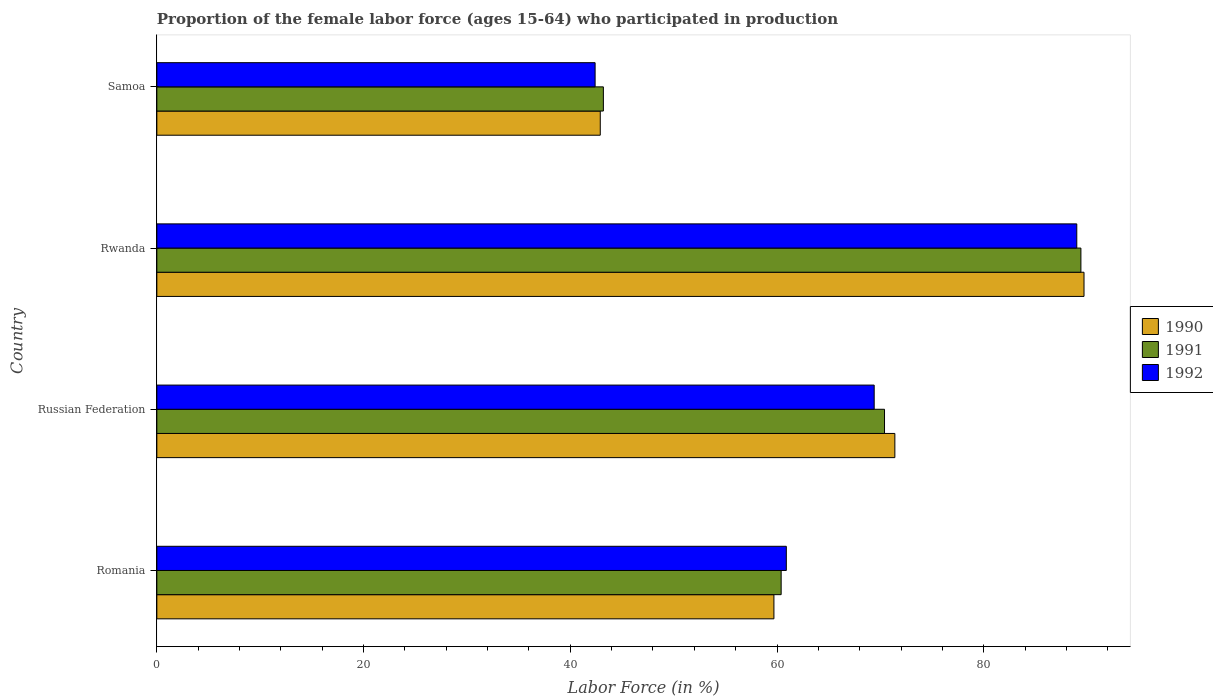How many groups of bars are there?
Your answer should be compact. 4. Are the number of bars per tick equal to the number of legend labels?
Provide a short and direct response. Yes. Are the number of bars on each tick of the Y-axis equal?
Ensure brevity in your answer.  Yes. How many bars are there on the 2nd tick from the top?
Keep it short and to the point. 3. What is the label of the 3rd group of bars from the top?
Provide a short and direct response. Russian Federation. In how many cases, is the number of bars for a given country not equal to the number of legend labels?
Your answer should be compact. 0. What is the proportion of the female labor force who participated in production in 1991 in Romania?
Your answer should be compact. 60.4. Across all countries, what is the maximum proportion of the female labor force who participated in production in 1991?
Ensure brevity in your answer.  89.4. Across all countries, what is the minimum proportion of the female labor force who participated in production in 1992?
Provide a short and direct response. 42.4. In which country was the proportion of the female labor force who participated in production in 1992 maximum?
Provide a short and direct response. Rwanda. In which country was the proportion of the female labor force who participated in production in 1992 minimum?
Keep it short and to the point. Samoa. What is the total proportion of the female labor force who participated in production in 1992 in the graph?
Your answer should be very brief. 261.7. What is the difference between the proportion of the female labor force who participated in production in 1990 in Romania and that in Rwanda?
Offer a very short reply. -30. What is the difference between the proportion of the female labor force who participated in production in 1992 in Russian Federation and the proportion of the female labor force who participated in production in 1991 in Rwanda?
Your response must be concise. -20. What is the average proportion of the female labor force who participated in production in 1992 per country?
Your answer should be very brief. 65.43. What is the difference between the proportion of the female labor force who participated in production in 1991 and proportion of the female labor force who participated in production in 1992 in Rwanda?
Ensure brevity in your answer.  0.4. What is the ratio of the proportion of the female labor force who participated in production in 1990 in Romania to that in Rwanda?
Your response must be concise. 0.67. Is the proportion of the female labor force who participated in production in 1990 in Russian Federation less than that in Rwanda?
Give a very brief answer. Yes. What is the difference between the highest and the lowest proportion of the female labor force who participated in production in 1991?
Provide a succinct answer. 46.2. What does the 3rd bar from the top in Rwanda represents?
Offer a very short reply. 1990. What does the 3rd bar from the bottom in Romania represents?
Your response must be concise. 1992. Are all the bars in the graph horizontal?
Your answer should be compact. Yes. Does the graph contain grids?
Give a very brief answer. No. How many legend labels are there?
Make the answer very short. 3. What is the title of the graph?
Keep it short and to the point. Proportion of the female labor force (ages 15-64) who participated in production. What is the Labor Force (in %) in 1990 in Romania?
Your response must be concise. 59.7. What is the Labor Force (in %) of 1991 in Romania?
Your response must be concise. 60.4. What is the Labor Force (in %) of 1992 in Romania?
Your answer should be compact. 60.9. What is the Labor Force (in %) of 1990 in Russian Federation?
Your response must be concise. 71.4. What is the Labor Force (in %) of 1991 in Russian Federation?
Your answer should be compact. 70.4. What is the Labor Force (in %) of 1992 in Russian Federation?
Make the answer very short. 69.4. What is the Labor Force (in %) of 1990 in Rwanda?
Give a very brief answer. 89.7. What is the Labor Force (in %) in 1991 in Rwanda?
Provide a succinct answer. 89.4. What is the Labor Force (in %) in 1992 in Rwanda?
Make the answer very short. 89. What is the Labor Force (in %) in 1990 in Samoa?
Offer a very short reply. 42.9. What is the Labor Force (in %) of 1991 in Samoa?
Keep it short and to the point. 43.2. What is the Labor Force (in %) of 1992 in Samoa?
Make the answer very short. 42.4. Across all countries, what is the maximum Labor Force (in %) of 1990?
Offer a very short reply. 89.7. Across all countries, what is the maximum Labor Force (in %) of 1991?
Your answer should be compact. 89.4. Across all countries, what is the maximum Labor Force (in %) of 1992?
Keep it short and to the point. 89. Across all countries, what is the minimum Labor Force (in %) in 1990?
Make the answer very short. 42.9. Across all countries, what is the minimum Labor Force (in %) in 1991?
Your answer should be compact. 43.2. Across all countries, what is the minimum Labor Force (in %) in 1992?
Provide a succinct answer. 42.4. What is the total Labor Force (in %) in 1990 in the graph?
Your answer should be very brief. 263.7. What is the total Labor Force (in %) in 1991 in the graph?
Ensure brevity in your answer.  263.4. What is the total Labor Force (in %) in 1992 in the graph?
Your response must be concise. 261.7. What is the difference between the Labor Force (in %) in 1990 in Romania and that in Rwanda?
Provide a succinct answer. -30. What is the difference between the Labor Force (in %) in 1992 in Romania and that in Rwanda?
Your answer should be very brief. -28.1. What is the difference between the Labor Force (in %) of 1991 in Romania and that in Samoa?
Give a very brief answer. 17.2. What is the difference between the Labor Force (in %) of 1992 in Romania and that in Samoa?
Keep it short and to the point. 18.5. What is the difference between the Labor Force (in %) in 1990 in Russian Federation and that in Rwanda?
Offer a terse response. -18.3. What is the difference between the Labor Force (in %) in 1992 in Russian Federation and that in Rwanda?
Make the answer very short. -19.6. What is the difference between the Labor Force (in %) in 1990 in Russian Federation and that in Samoa?
Provide a short and direct response. 28.5. What is the difference between the Labor Force (in %) of 1991 in Russian Federation and that in Samoa?
Make the answer very short. 27.2. What is the difference between the Labor Force (in %) of 1990 in Rwanda and that in Samoa?
Provide a succinct answer. 46.8. What is the difference between the Labor Force (in %) of 1991 in Rwanda and that in Samoa?
Your answer should be very brief. 46.2. What is the difference between the Labor Force (in %) of 1992 in Rwanda and that in Samoa?
Ensure brevity in your answer.  46.6. What is the difference between the Labor Force (in %) in 1990 in Romania and the Labor Force (in %) in 1991 in Russian Federation?
Provide a short and direct response. -10.7. What is the difference between the Labor Force (in %) in 1990 in Romania and the Labor Force (in %) in 1992 in Russian Federation?
Offer a very short reply. -9.7. What is the difference between the Labor Force (in %) of 1991 in Romania and the Labor Force (in %) of 1992 in Russian Federation?
Your answer should be compact. -9. What is the difference between the Labor Force (in %) in 1990 in Romania and the Labor Force (in %) in 1991 in Rwanda?
Your response must be concise. -29.7. What is the difference between the Labor Force (in %) of 1990 in Romania and the Labor Force (in %) of 1992 in Rwanda?
Keep it short and to the point. -29.3. What is the difference between the Labor Force (in %) in 1991 in Romania and the Labor Force (in %) in 1992 in Rwanda?
Provide a short and direct response. -28.6. What is the difference between the Labor Force (in %) in 1990 in Romania and the Labor Force (in %) in 1992 in Samoa?
Provide a succinct answer. 17.3. What is the difference between the Labor Force (in %) of 1990 in Russian Federation and the Labor Force (in %) of 1991 in Rwanda?
Keep it short and to the point. -18. What is the difference between the Labor Force (in %) of 1990 in Russian Federation and the Labor Force (in %) of 1992 in Rwanda?
Keep it short and to the point. -17.6. What is the difference between the Labor Force (in %) in 1991 in Russian Federation and the Labor Force (in %) in 1992 in Rwanda?
Make the answer very short. -18.6. What is the difference between the Labor Force (in %) of 1990 in Russian Federation and the Labor Force (in %) of 1991 in Samoa?
Give a very brief answer. 28.2. What is the difference between the Labor Force (in %) of 1990 in Rwanda and the Labor Force (in %) of 1991 in Samoa?
Ensure brevity in your answer.  46.5. What is the difference between the Labor Force (in %) in 1990 in Rwanda and the Labor Force (in %) in 1992 in Samoa?
Make the answer very short. 47.3. What is the difference between the Labor Force (in %) in 1991 in Rwanda and the Labor Force (in %) in 1992 in Samoa?
Your answer should be compact. 47. What is the average Labor Force (in %) in 1990 per country?
Your answer should be compact. 65.92. What is the average Labor Force (in %) in 1991 per country?
Your answer should be compact. 65.85. What is the average Labor Force (in %) of 1992 per country?
Give a very brief answer. 65.42. What is the difference between the Labor Force (in %) of 1990 and Labor Force (in %) of 1991 in Romania?
Offer a very short reply. -0.7. What is the difference between the Labor Force (in %) in 1990 and Labor Force (in %) in 1992 in Romania?
Offer a terse response. -1.2. What is the difference between the Labor Force (in %) of 1990 and Labor Force (in %) of 1992 in Russian Federation?
Make the answer very short. 2. What is the difference between the Labor Force (in %) of 1990 and Labor Force (in %) of 1991 in Rwanda?
Your answer should be compact. 0.3. What is the difference between the Labor Force (in %) of 1991 and Labor Force (in %) of 1992 in Rwanda?
Provide a succinct answer. 0.4. What is the ratio of the Labor Force (in %) of 1990 in Romania to that in Russian Federation?
Offer a very short reply. 0.84. What is the ratio of the Labor Force (in %) of 1991 in Romania to that in Russian Federation?
Your answer should be compact. 0.86. What is the ratio of the Labor Force (in %) in 1992 in Romania to that in Russian Federation?
Keep it short and to the point. 0.88. What is the ratio of the Labor Force (in %) in 1990 in Romania to that in Rwanda?
Keep it short and to the point. 0.67. What is the ratio of the Labor Force (in %) of 1991 in Romania to that in Rwanda?
Provide a succinct answer. 0.68. What is the ratio of the Labor Force (in %) of 1992 in Romania to that in Rwanda?
Keep it short and to the point. 0.68. What is the ratio of the Labor Force (in %) in 1990 in Romania to that in Samoa?
Offer a very short reply. 1.39. What is the ratio of the Labor Force (in %) in 1991 in Romania to that in Samoa?
Your response must be concise. 1.4. What is the ratio of the Labor Force (in %) in 1992 in Romania to that in Samoa?
Offer a terse response. 1.44. What is the ratio of the Labor Force (in %) in 1990 in Russian Federation to that in Rwanda?
Offer a terse response. 0.8. What is the ratio of the Labor Force (in %) in 1991 in Russian Federation to that in Rwanda?
Provide a succinct answer. 0.79. What is the ratio of the Labor Force (in %) in 1992 in Russian Federation to that in Rwanda?
Your response must be concise. 0.78. What is the ratio of the Labor Force (in %) in 1990 in Russian Federation to that in Samoa?
Ensure brevity in your answer.  1.66. What is the ratio of the Labor Force (in %) in 1991 in Russian Federation to that in Samoa?
Your answer should be compact. 1.63. What is the ratio of the Labor Force (in %) of 1992 in Russian Federation to that in Samoa?
Your response must be concise. 1.64. What is the ratio of the Labor Force (in %) of 1990 in Rwanda to that in Samoa?
Your response must be concise. 2.09. What is the ratio of the Labor Force (in %) in 1991 in Rwanda to that in Samoa?
Provide a short and direct response. 2.07. What is the ratio of the Labor Force (in %) in 1992 in Rwanda to that in Samoa?
Provide a succinct answer. 2.1. What is the difference between the highest and the second highest Labor Force (in %) in 1990?
Provide a succinct answer. 18.3. What is the difference between the highest and the second highest Labor Force (in %) of 1992?
Ensure brevity in your answer.  19.6. What is the difference between the highest and the lowest Labor Force (in %) in 1990?
Your answer should be compact. 46.8. What is the difference between the highest and the lowest Labor Force (in %) of 1991?
Make the answer very short. 46.2. What is the difference between the highest and the lowest Labor Force (in %) of 1992?
Give a very brief answer. 46.6. 